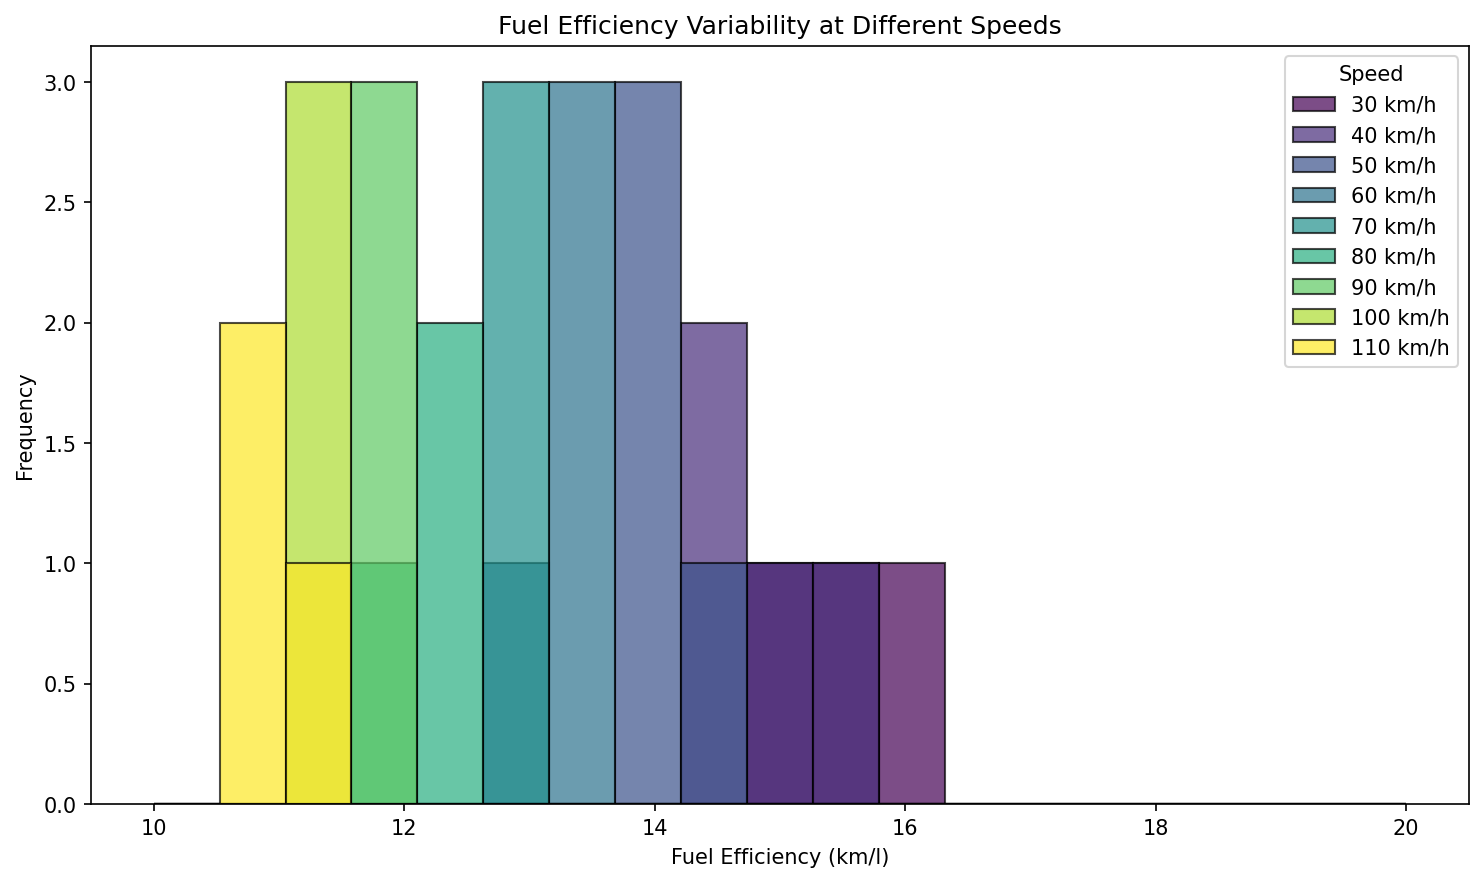Which speed has the highest frequency of fuel efficiency between 11 and 12 km/l? The histogram bins between 11 and 12 km/l show that the highest bar belongs to the 100 km/h speed. This bar is taller compared to other speeds in this range, which indicates a higher frequency.
Answer: 100 km/h Which speed shows the widest range of fuel efficiency values? Observing the span of the bars for each speed, 30 km/h shows the widest range extending from approximately 14.9 km/l to 16.2 km/l. This is broader than the range of other speeds.
Answer: 30 km/h At which speed does fuel efficiency show more variability between 12 and 13 km/l? The histogram bins between 12 and 13 km/l for 60 km/h and 70 km/h speeds have more bars of varying heights, indicating greater variability, especially for 70 km/h.
Answer: 70 km/h How does the frequency of fuel efficiency values at 110 km/h compare to that at 50 km/h? The histogram for 110 km/h shows fewer bars and lower frequencies overall compared to the histogram for 50 km/h, which shows several bars clustered around 14 km/l with higher frequencies.
Answer: Fewer at 110 km/h Which speed has bars that are the most evenly spaced in height around 14.5 km/l? For 40 km/h, the bars around 14.5 km/l are evenly spaced, indicating a consistent frequency in fuel efficiency values around this range.
Answer: 40 km/h What's the difference in fuel efficiency range between 80 km/h and 30 km/h? The fuel efficiency for 80 km/h ranges roughly from 12.1 to 12.3 km/l, a narrow range of 0.2 km/l. For 30 km/h, the range is 14.9 to 16.2 km/l, which gives a wider range of 1.3 km/l. The difference in range is 1.3 - 0.2 = 1.1 km/l.
Answer: 1.1 km/l Which speed has the least frequency of fuel efficiency values above 14 km/l? The 110 km/h and 100 km/h speeds have bars mostly below 14 km/l. Specifically, no bars in the 110 km/h range extend above 14 km/l.
Answer: 110 km/h What is the common trend in fuel efficiency as speed increases from 30 km/h to 110 km/h? Observing the histograms, as speed increases from 30 km/h to 110 km/h, the bars shift towards lower fuel efficiency values, indicating a general decrease in fuel efficiency.
Answer: Decreases Which speed range has all its bars below the 13 km/l mark? The speed range for 100 km/h shows all bars below the 13 km/l mark, indicating all fuel efficiency values for this speed are below 13 km/l.
Answer: 100 km/h At which specific fuel efficiency value do all speeds have at least one histogram bar? Since no single fuel efficiency value (bin) contains bars for all speeds, this value does not exist in the current data distribution.
Answer: None 